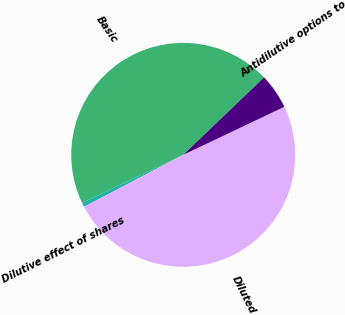<chart> <loc_0><loc_0><loc_500><loc_500><pie_chart><fcel>Basic<fcel>Dilutive effect of shares<fcel>Diluted<fcel>Antidilutive options to<nl><fcel>44.9%<fcel>0.62%<fcel>49.38%<fcel>5.1%<nl></chart> 